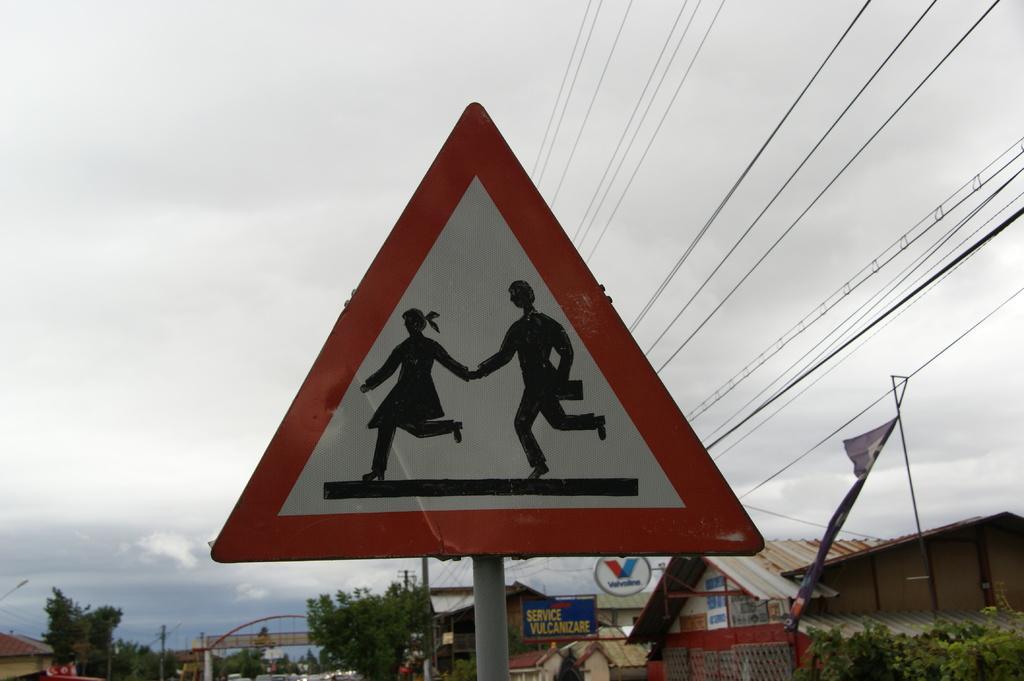Can you describe this image briefly? This picture is clicked outside. In the center there is a board attached to the pole and we can see the picture of two persons on the board. In the background we can see the cables, houses, trees, boards, metal rods and the sky. 